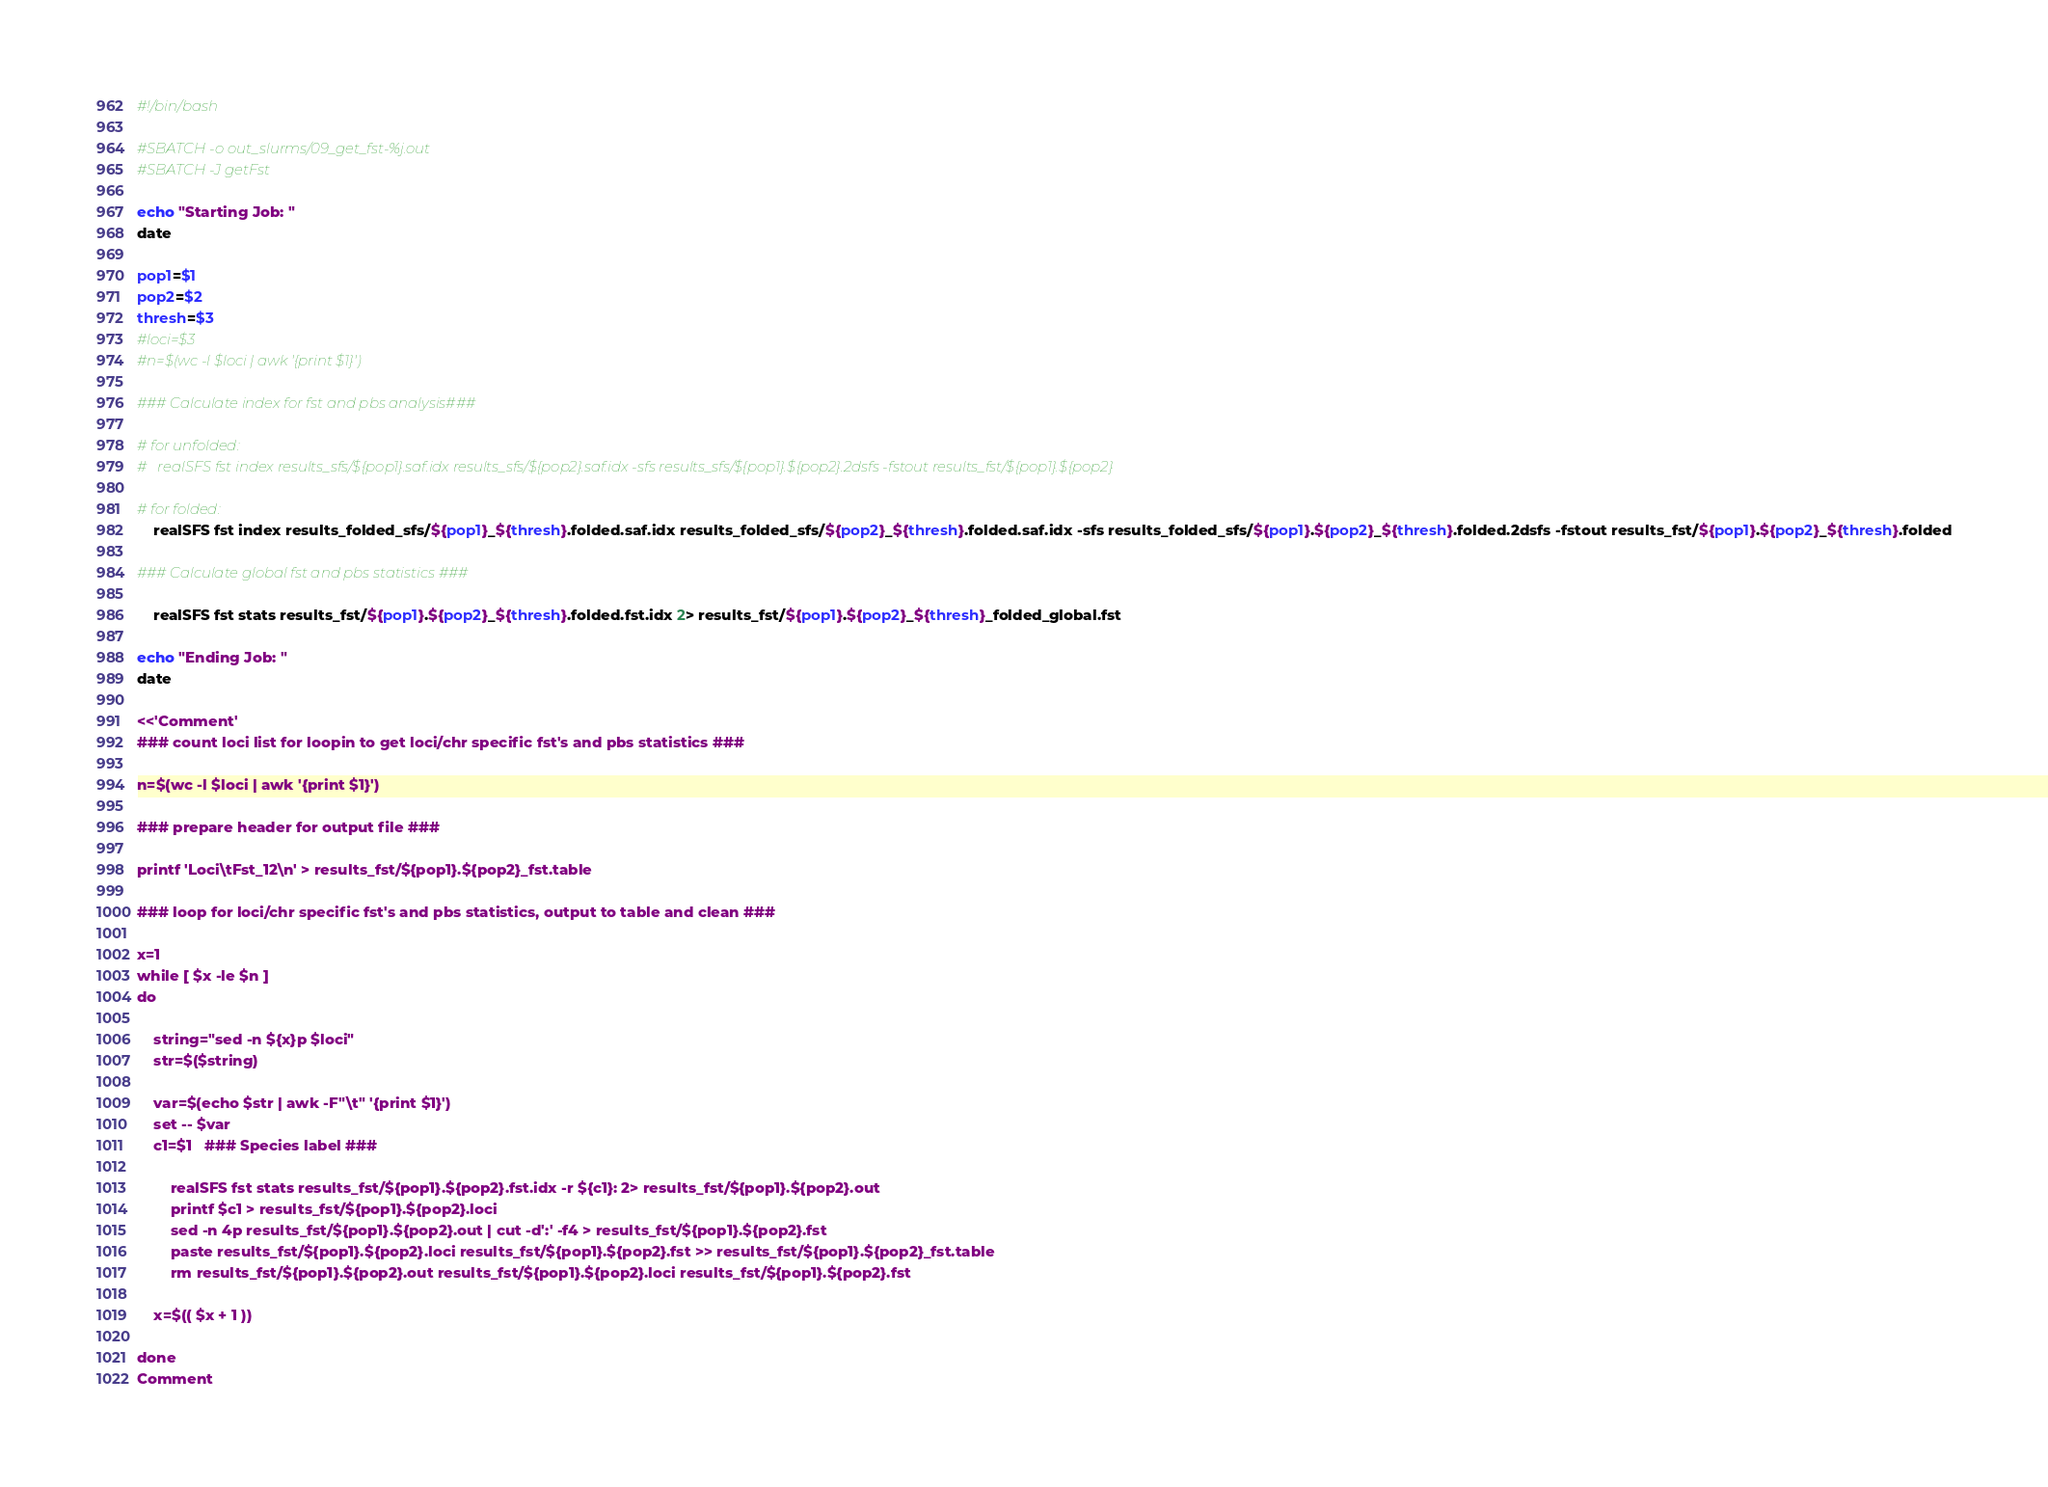Convert code to text. <code><loc_0><loc_0><loc_500><loc_500><_Bash_>#!/bin/bash

#SBATCH -o out_slurms/09_get_fst-%j.out
#SBATCH -J getFst

echo "Starting Job: "
date

pop1=$1
pop2=$2
thresh=$3
#loci=$3
#n=$(wc -l $loci | awk '{print $1}')

### Calculate index for fst and pbs analysis###

# for unfolded:
#	realSFS fst index results_sfs/${pop1}.saf.idx results_sfs/${pop2}.saf.idx -sfs results_sfs/${pop1}.${pop2}.2dsfs -fstout results_fst/${pop1}.${pop2}

# for folded:
	realSFS fst index results_folded_sfs/${pop1}_${thresh}.folded.saf.idx results_folded_sfs/${pop2}_${thresh}.folded.saf.idx -sfs results_folded_sfs/${pop1}.${pop2}_${thresh}.folded.2dsfs -fstout results_fst/${pop1}.${pop2}_${thresh}.folded

### Calculate global fst and pbs statistics ###

	realSFS fst stats results_fst/${pop1}.${pop2}_${thresh}.folded.fst.idx 2> results_fst/${pop1}.${pop2}_${thresh}_folded_global.fst

echo "Ending Job: "
date

<<'Comment'
### count loci list for loopin to get loci/chr specific fst's and pbs statistics ###

n=$(wc -l $loci | awk '{print $1}')

### prepare header for output file ###

printf 'Loci\tFst_12\n' > results_fst/${pop1}.${pop2}_fst.table

### loop for loci/chr specific fst's and pbs statistics, output to table and clean ###

x=1
while [ $x -le $n ] 
do

	string="sed -n ${x}p $loci"
	str=$($string)

	var=$(echo $str | awk -F"\t" '{print $1}')
	set -- $var
	c1=$1   ### Species label ###
	
		realSFS fst stats results_fst/${pop1}.${pop2}.fst.idx -r ${c1}: 2> results_fst/${pop1}.${pop2}.out
		printf $c1 > results_fst/${pop1}.${pop2}.loci
		sed -n 4p results_fst/${pop1}.${pop2}.out | cut -d':' -f4 > results_fst/${pop1}.${pop2}.fst
		paste results_fst/${pop1}.${pop2}.loci results_fst/${pop1}.${pop2}.fst >> results_fst/${pop1}.${pop2}_fst.table
		rm results_fst/${pop1}.${pop2}.out results_fst/${pop1}.${pop2}.loci results_fst/${pop1}.${pop2}.fst

	x=$(( $x + 1 ))

done
Comment
</code> 